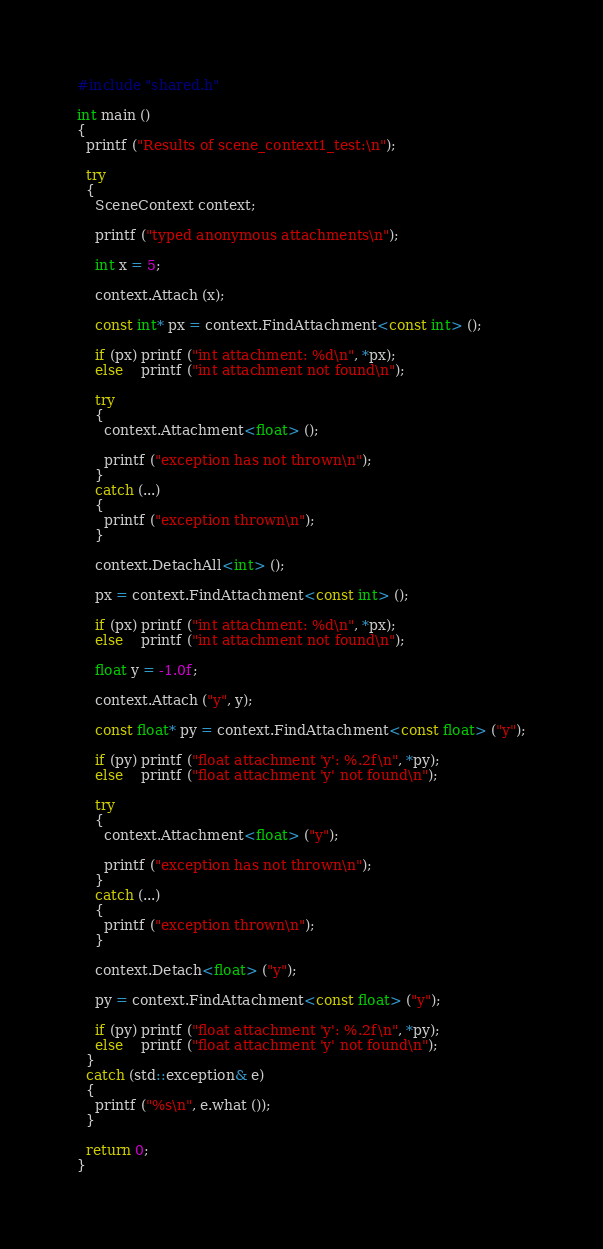<code> <loc_0><loc_0><loc_500><loc_500><_C++_>#include "shared.h"

int main ()
{
  printf ("Results of scene_context1_test:\n");
  
  try
  {
    SceneContext context;
    
    printf ("typed anonymous attachments\n");
    
    int x = 5;
    
    context.Attach (x);
    
    const int* px = context.FindAttachment<const int> ();
    
    if (px) printf ("int attachment: %d\n", *px);
    else    printf ("int attachment not found\n");
    
    try
    {
      context.Attachment<float> ();

      printf ("exception has not thrown\n");
    }
    catch (...)
    {
      printf ("exception thrown\n");
    }
    
    context.DetachAll<int> ();
    
    px = context.FindAttachment<const int> ();
    
    if (px) printf ("int attachment: %d\n", *px);
    else    printf ("int attachment not found\n");    
    
    float y = -1.0f;
    
    context.Attach ("y", y);
    
    const float* py = context.FindAttachment<const float> ("y");

    if (py) printf ("float attachment 'y': %.2f\n", *py);
    else    printf ("float attachment 'y' not found\n");
    
    try
    {
      context.Attachment<float> ("y");

      printf ("exception has not thrown\n");
    }
    catch (...)
    {
      printf ("exception thrown\n");
    }
    
    context.Detach<float> ("y");
    
    py = context.FindAttachment<const float> ("y");

    if (py) printf ("float attachment 'y': %.2f\n", *py);
    else    printf ("float attachment 'y' not found\n");
  }
  catch (std::exception& e)
  {
    printf ("%s\n", e.what ());
  }

  return 0;
}
</code> 